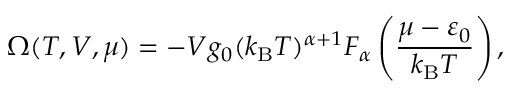Convert formula to latex. <formula><loc_0><loc_0><loc_500><loc_500>\Omega ( T , V , \mu ) = - V g _ { 0 } ( k _ { B } T ) ^ { \alpha + 1 } F _ { \alpha } \left ( { \frac { \mu - \varepsilon _ { 0 } } { k _ { B } T } } \right ) ,</formula> 